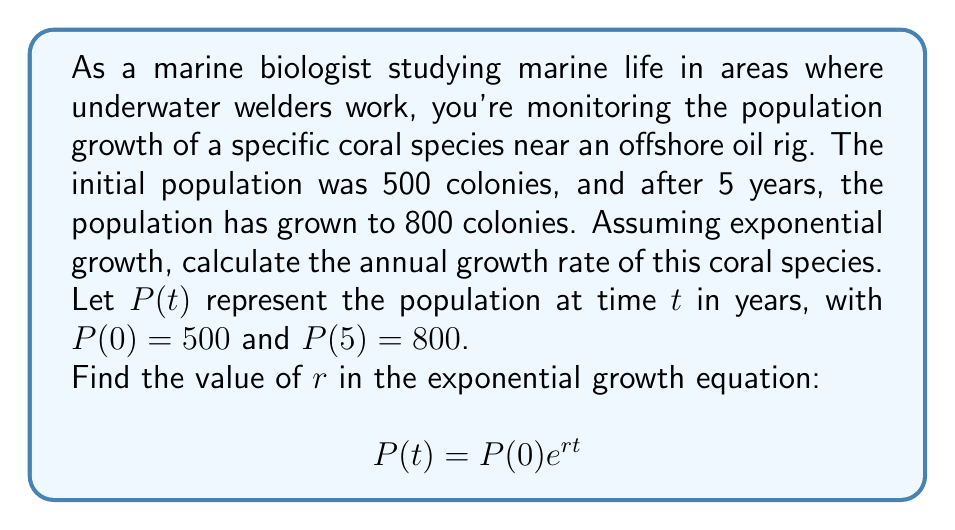Give your solution to this math problem. To solve this problem, we'll use the exponential growth equation and the given information:

1) The general form of the exponential growth equation is:
   $$P(t) = P(0)e^{rt}$$
   where $P(0)$ is the initial population, $r$ is the growth rate, and $t$ is the time.

2) We know that:
   $P(0) = 500$ (initial population)
   $P(5) = 800$ (population after 5 years)
   $t = 5$ years

3) Let's substitute these values into the equation:
   $$800 = 500e^{r(5)}$$

4) Divide both sides by 500:
   $$\frac{800}{500} = e^{5r}$$

5) Take the natural logarithm of both sides:
   $$\ln(\frac{800}{500}) = 5r$$

6) Simplify the left side:
   $$\ln(1.6) = 5r$$

7) Solve for $r$:
   $$r = \frac{\ln(1.6)}{5}$$

8) Calculate the value:
   $$r = \frac{0.47000362924573563}{5} \approx 0.0940$$

Therefore, the annual growth rate is approximately 0.0940 or 9.40% per year.
Answer: $r \approx 0.0940$ or 9.40% per year 